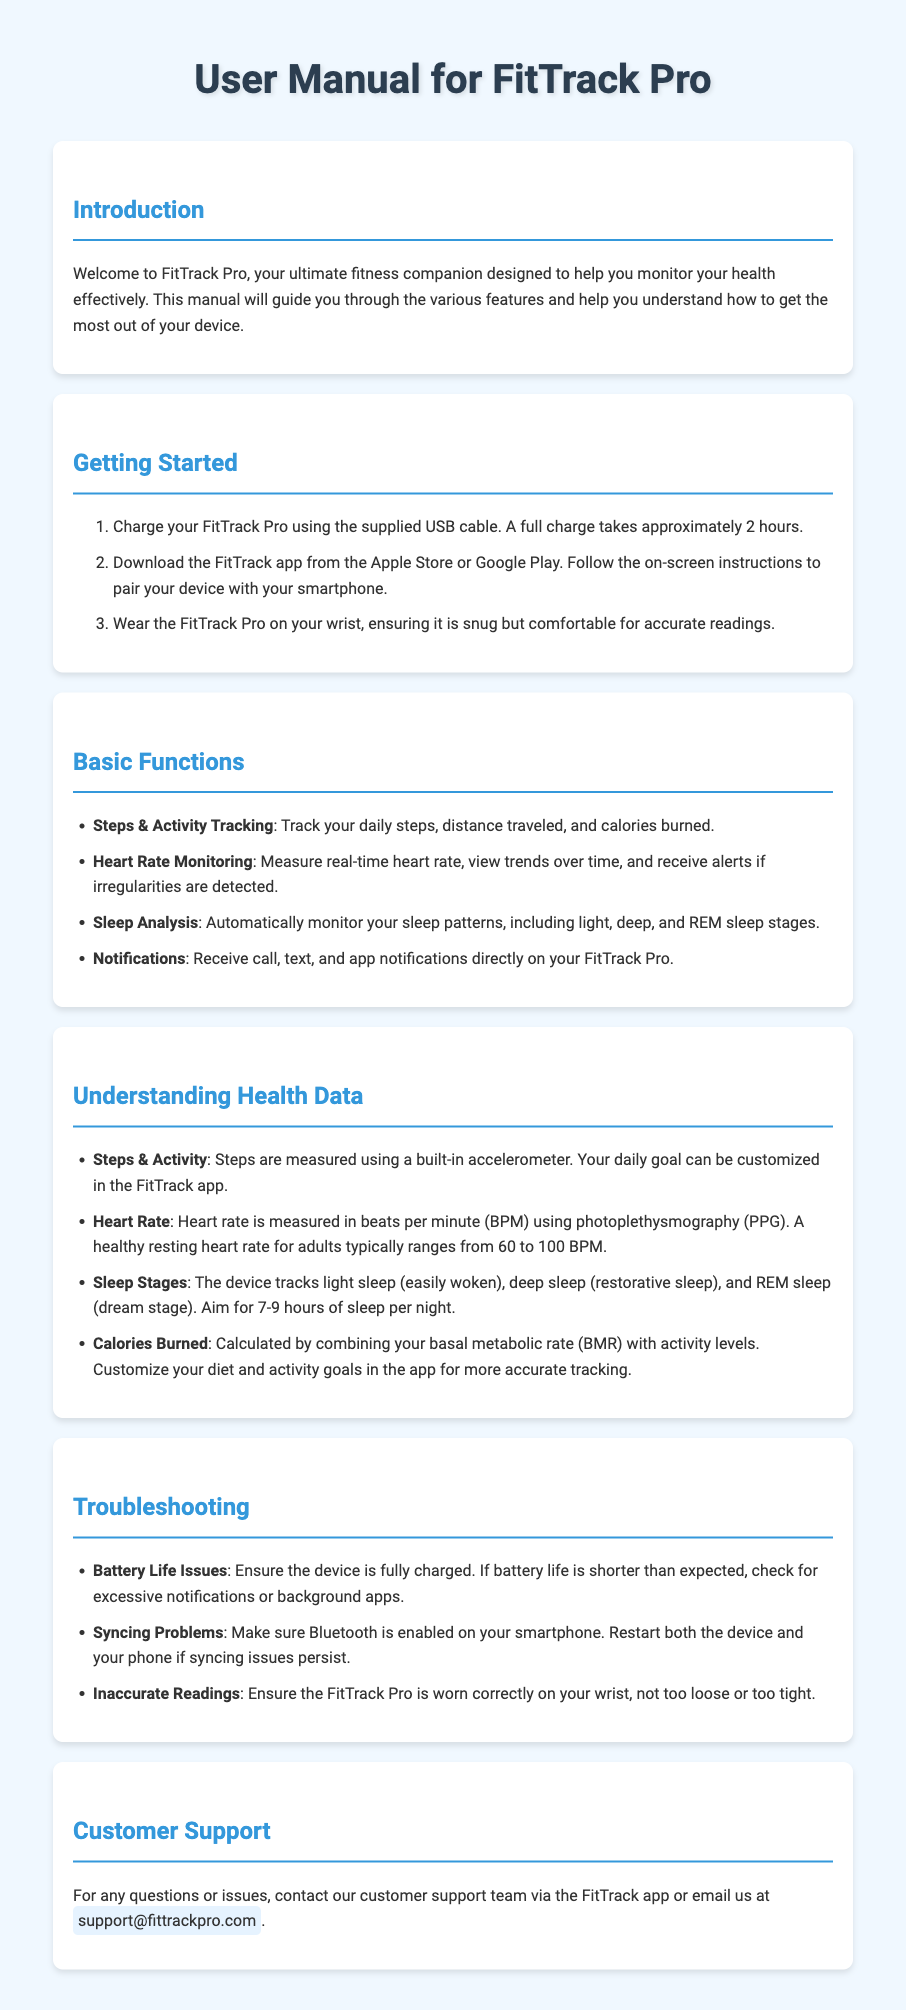What is the device called? The document introduces the device as FitTrack Pro in the introduction section.
Answer: FitTrack Pro How long does a full charge take? The "Getting Started" section states that a full charge takes approximately 2 hours.
Answer: 2 hours What is the weight range for a healthy resting heart rate? The section on Understanding Health Data specifies that a healthy resting heart rate typically ranges from 60 to 100 BPM.
Answer: 60 to 100 BPM What are the sleep stages tracked by the device? The Understanding Health Data section lists light sleep, deep sleep, and REM sleep as tracked stages.
Answer: light sleep, deep sleep, and REM sleep What should you check if you have syncing problems? The Troubleshooting section mentions ensuring that Bluetooth is enabled on your smartphone if there are syncing issues.
Answer: Bluetooth is enabled What is the support email address for customer service? The Customer Support section provides the email address for support as support@fittrackpro.com.
Answer: support@fittrackpro.com What feature allows you to receive notifications? The Basic Functions section lists Notifications as a feature of the device.
Answer: Notifications How can you customize your daily activity goals? The Understanding Health Data section mentions customizing your daily goal in the FitTrack app.
Answer: FitTrack app What should you do if battery life is shorter than expected? The Troubleshooting section advises checking for excessive notifications or background apps if battery life issues occur.
Answer: Check for excessive notifications or background apps 